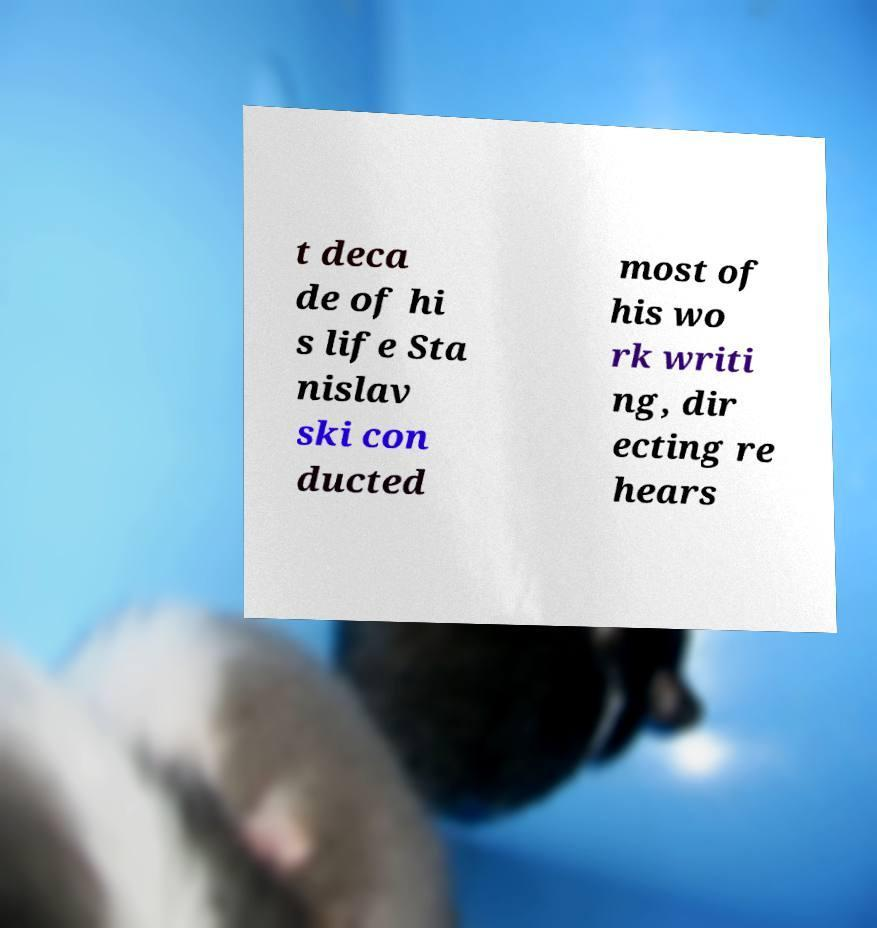Please identify and transcribe the text found in this image. t deca de of hi s life Sta nislav ski con ducted most of his wo rk writi ng, dir ecting re hears 